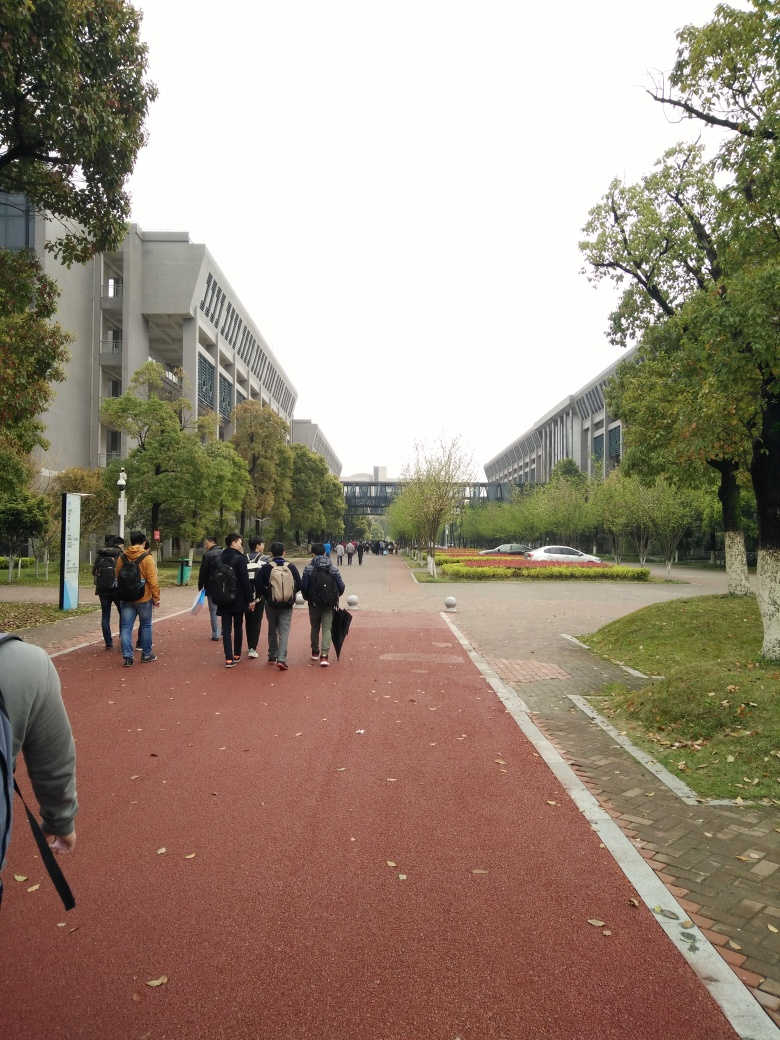Are the colors in the image rich? Upon review, it seems the image possesses a relatively muted color palette; however, the colors do not appear to be overly dull or washed out. The image strikes a balance with natural tones that represent an overcast day, which implies a softness to the colors present rather than a vivid richness. A slight gray overcast can be observed, suggesting a lack of strong sunlight to bring out more vibrant hues. 